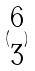Convert formula to latex. <formula><loc_0><loc_0><loc_500><loc_500>( \begin{matrix} 6 \\ 3 \end{matrix} )</formula> 